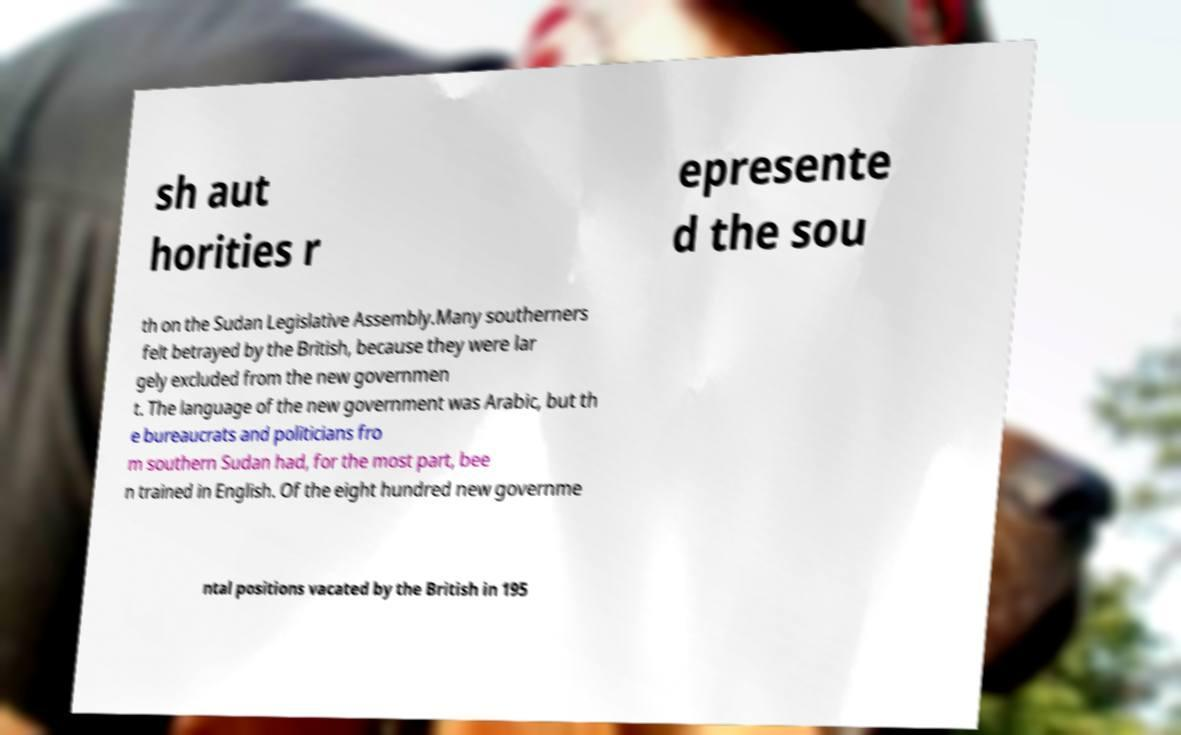Please read and relay the text visible in this image. What does it say? sh aut horities r epresente d the sou th on the Sudan Legislative Assembly.Many southerners felt betrayed by the British, because they were lar gely excluded from the new governmen t. The language of the new government was Arabic, but th e bureaucrats and politicians fro m southern Sudan had, for the most part, bee n trained in English. Of the eight hundred new governme ntal positions vacated by the British in 195 